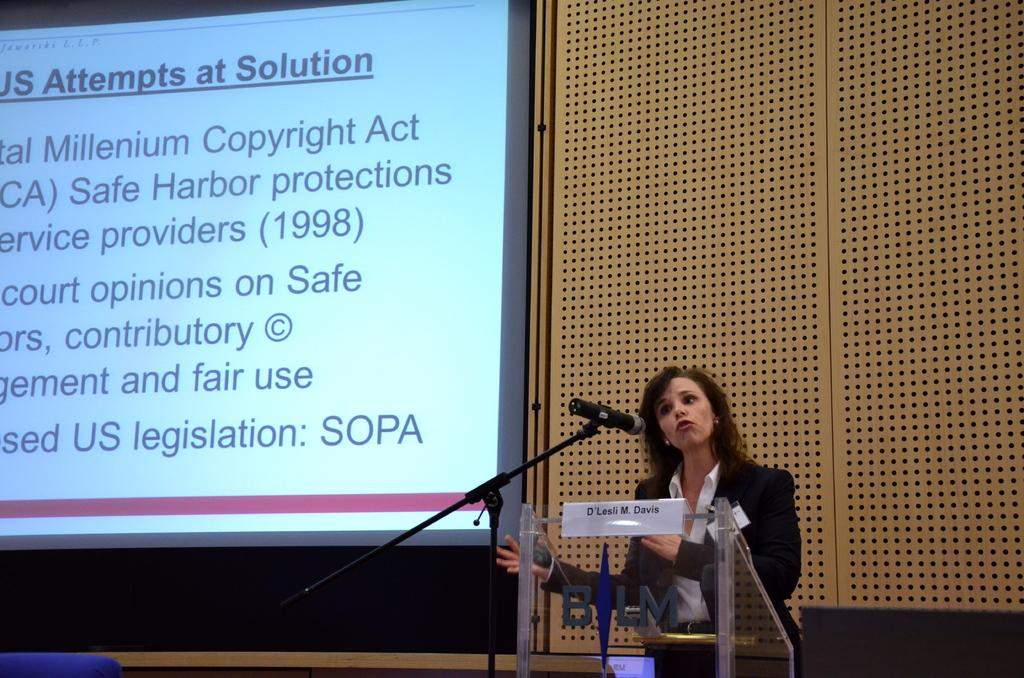Who is present in the image? There is a lady in the image. What is the lady standing beside? The lady is standing beside a glass table. What object can be seen in the image that is typically used for amplifying sound? There is a microphone stand in the image. What is visible on the wall in the background of the image? There is a screen on the wall in the background. How many houses are visible in the image? There are no houses visible in the image. What type of wax is being used by the lady in the image? There is no wax present in the image, and the lady is not using any wax. 